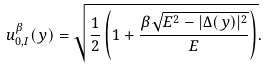Convert formula to latex. <formula><loc_0><loc_0><loc_500><loc_500>u ^ { \beta } _ { 0 , I } ( y ) = \sqrt { \frac { 1 } { 2 } \left ( 1 + \frac { \beta \sqrt { E ^ { 2 } - | \Delta ( y ) | ^ { 2 } } } { E } \right ) } .</formula> 